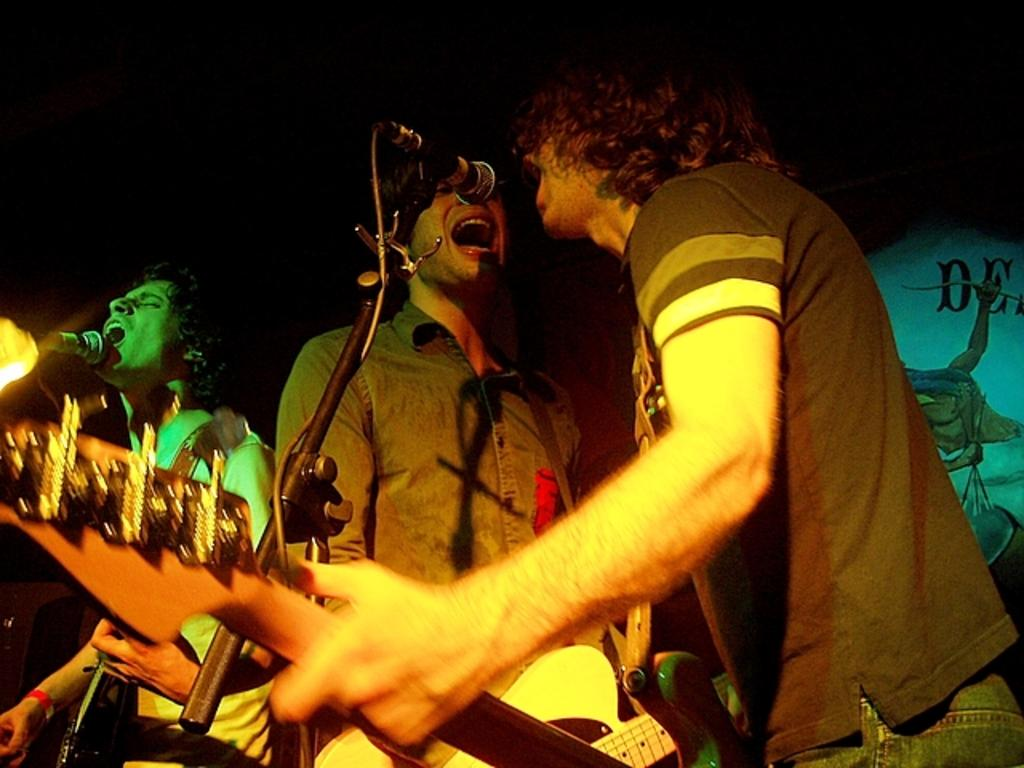How many people are in the image? There are three persons in the image. What are the persons doing in the image? The persons are standing and singing. What instruments are the persons holding? The persons are holding guitars. What is in front of the persons for amplifying their voices? There is a microphone in front of the persons. What can be seen in the background of the image? There is a wall in the background of the image. What type of form is the carpenter using to stitch the fabric in the image? There is no carpenter or fabric present in the image; it features three persons singing with guitars and a microphone. 